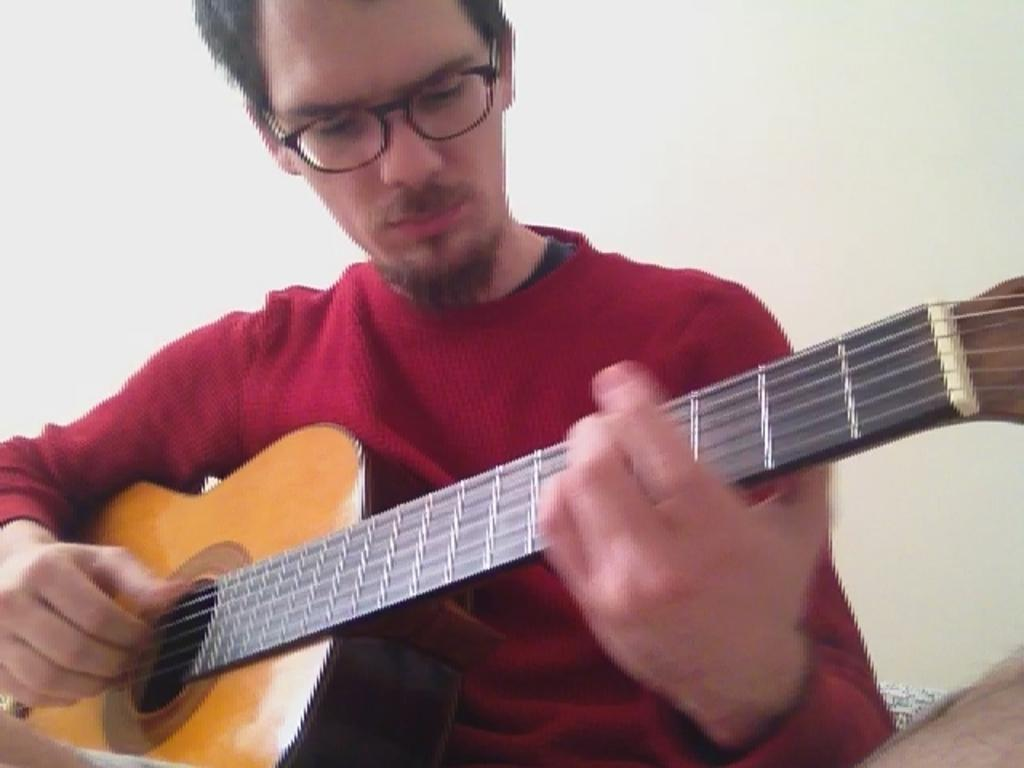Who is the main subject in the image? There is a man in the image. What is the man wearing? The man is wearing a red t-shirt. What accessory is the man wearing? The man is wearing spectacles. What is the man doing in the image? The man is playing a guitar. How is the man holding the guitar? The man is holding the guitar in his hands. What type of bean is being used as a prop in the image? There is no bean present in the image; the man is playing a guitar. 